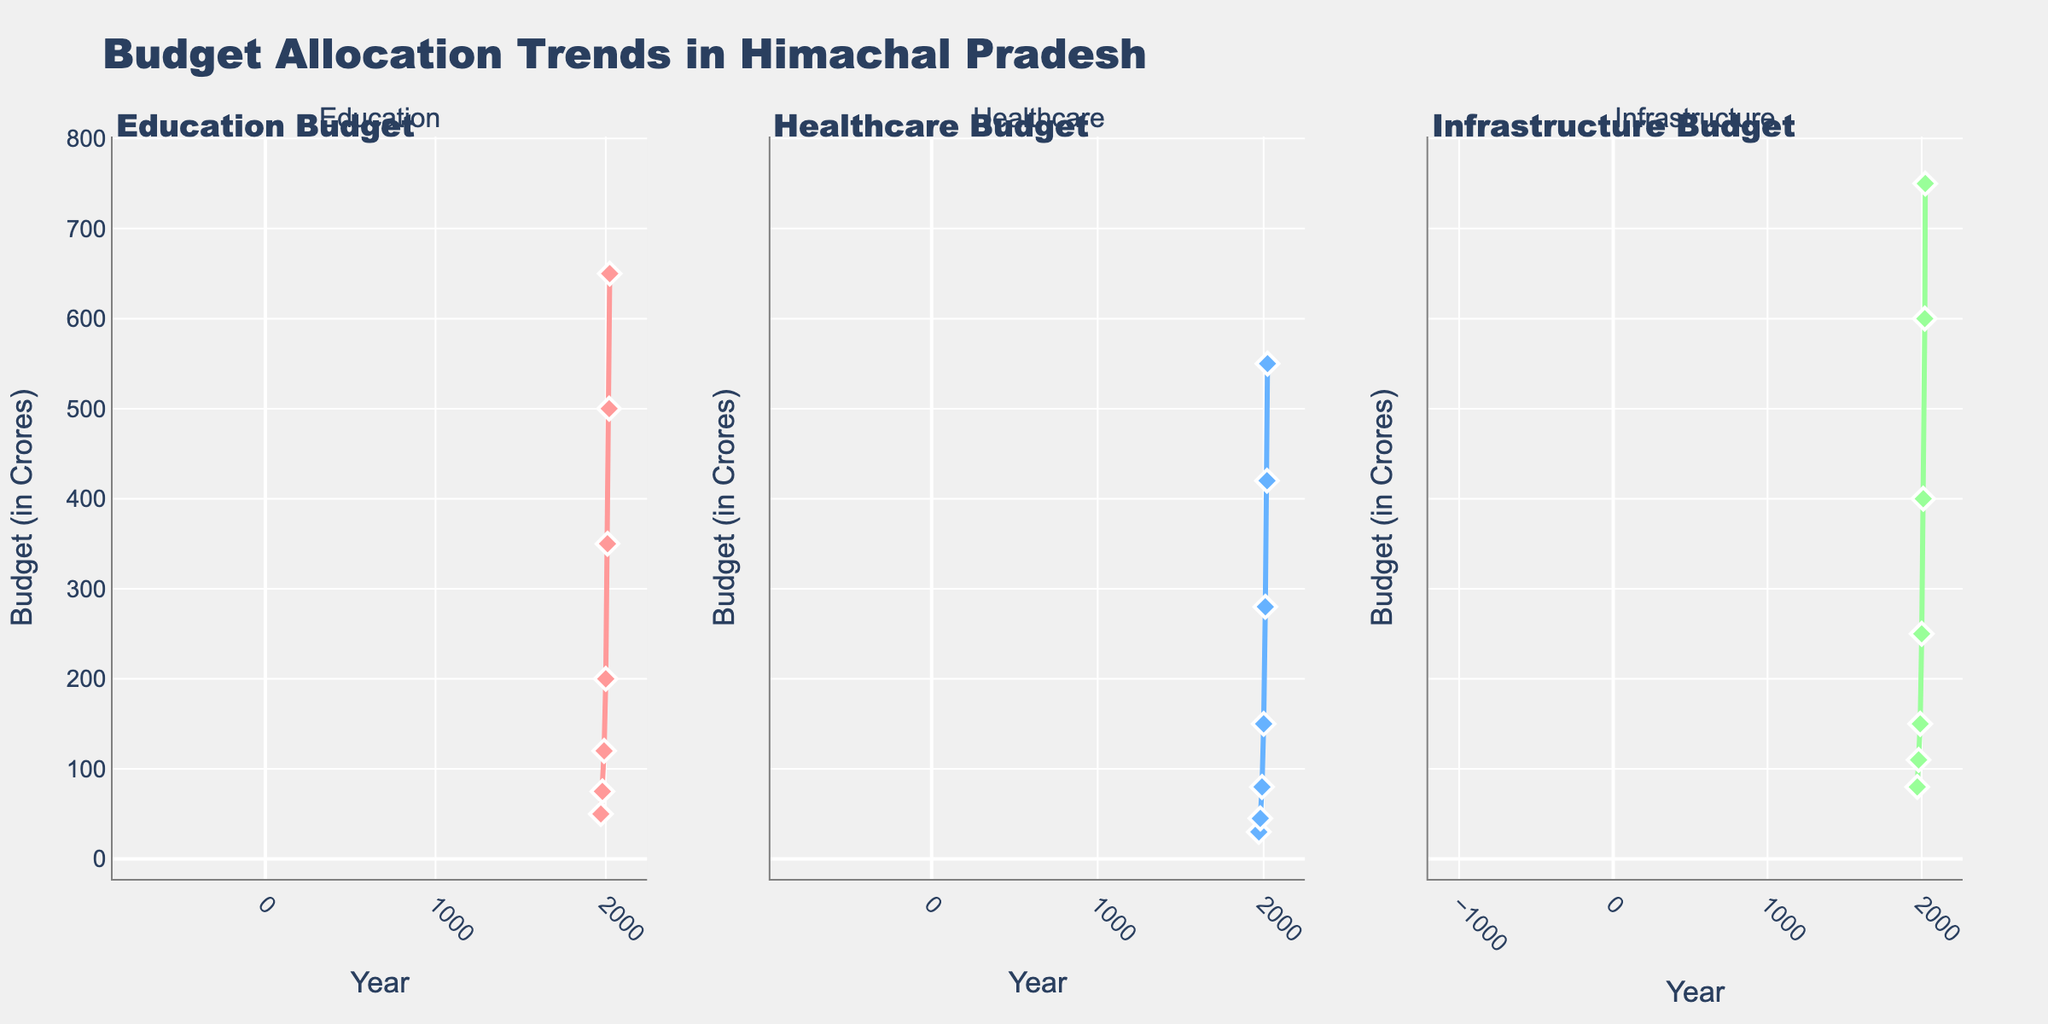What is the title of the figure? The title of the figure is written at the top and is stated as "Budget Allocation Trends in Himachal Pradesh".
Answer: Budget Allocation Trends in Himachal Pradesh Which sector shows the highest budget allocation in 2023? The Infrastructure sector exhibits the highest budget allocation in 2023, as indicated by the peak value of its line plot clearly surpassing the other sectors.
Answer: Infrastructure How has the budget allocation for Education changed from 1971 to 2023? The budget for Education has increased from 50 crores in 1971 to 650 crores in 2023. This is marked by the continuous upward trend in the Education subplot.
Answer: Increased from 50 to 650 crores Which sector had a budget allocation of 80 crores in 1990? By tracing back to the 1990 marker in the subplot, it is clear that the Healthcare sector had an allocation of 80 crores at that point.
Answer: Healthcare What is the difference in budget allocation between Healthcare and Education in 2020? In 2020, the budget allocation for Healthcare was 420 crores, while Education was 500 crores. The difference is calculated as 500 - 420.
Answer: 80 crores Between 2000 and 2010, which sector saw the largest increase in budget allocation? The Infrastructure sector increased from 250 crores to 400 crores between 2000 and 2010, which is the largest increase (150 crores) compared to Education and Healthcare.
Answer: Infrastructure How many data points are there for each sector in the plot? Each sector has data points marked for the years 1971, 1980, 1990, 2000, 2010, 2020, and 2023, totaling seven points per subplot.
Answer: Seven In which decade did the budget for Education exceed 200 crores for the first time? The Education budget exceeded 200 crores between 1990 and 2000, as seen in the 2000 data point showing 200 crores.
Answer: 1990-2000 Compare the rate of increase in budget allocation for Healthcare and Infrastructure from 1971 to 1980. Healthcare increased from 30 to 45 crores, an increase of 15 crores. Infrastructure rose from 80 to 110 crores, an increase of 30 crores. Therefore, Infrastructure's rate of increase is higher.
Answer: Infrastructure What trends can be observed in the budget allocation for major sectors in Himachal Pradesh over the years? A steady positive trend is visible with increasing budget allocations for all three sectors: Education, Healthcare, and Infrastructure, reflecting prioritization and growth in these sectors.
Answer: Increasing trend in all sectors 